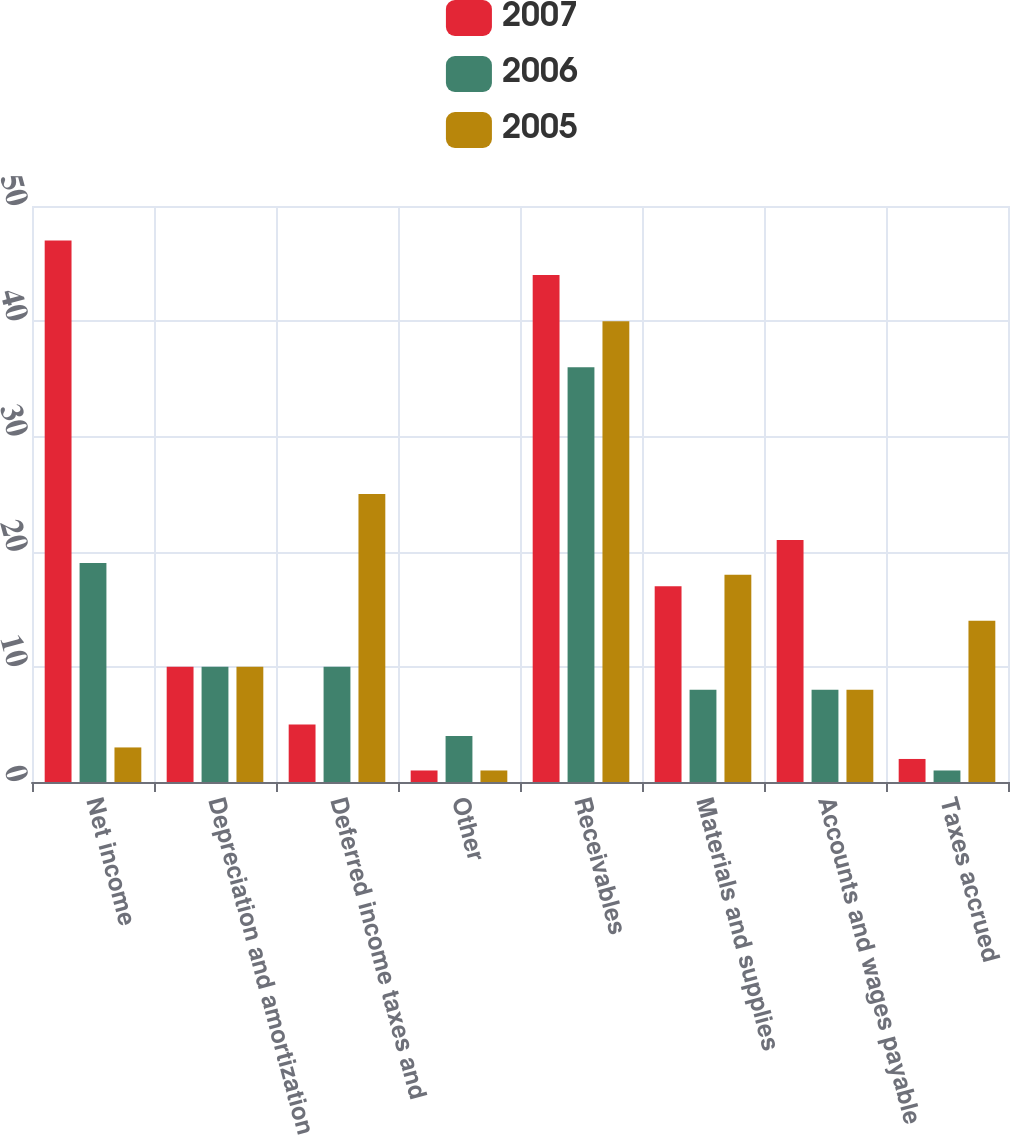Convert chart to OTSL. <chart><loc_0><loc_0><loc_500><loc_500><stacked_bar_chart><ecel><fcel>Net income<fcel>Depreciation and amortization<fcel>Deferred income taxes and<fcel>Other<fcel>Receivables<fcel>Materials and supplies<fcel>Accounts and wages payable<fcel>Taxes accrued<nl><fcel>2007<fcel>47<fcel>10<fcel>5<fcel>1<fcel>44<fcel>17<fcel>21<fcel>2<nl><fcel>2006<fcel>19<fcel>10<fcel>10<fcel>4<fcel>36<fcel>8<fcel>8<fcel>1<nl><fcel>2005<fcel>3<fcel>10<fcel>25<fcel>1<fcel>40<fcel>18<fcel>8<fcel>14<nl></chart> 